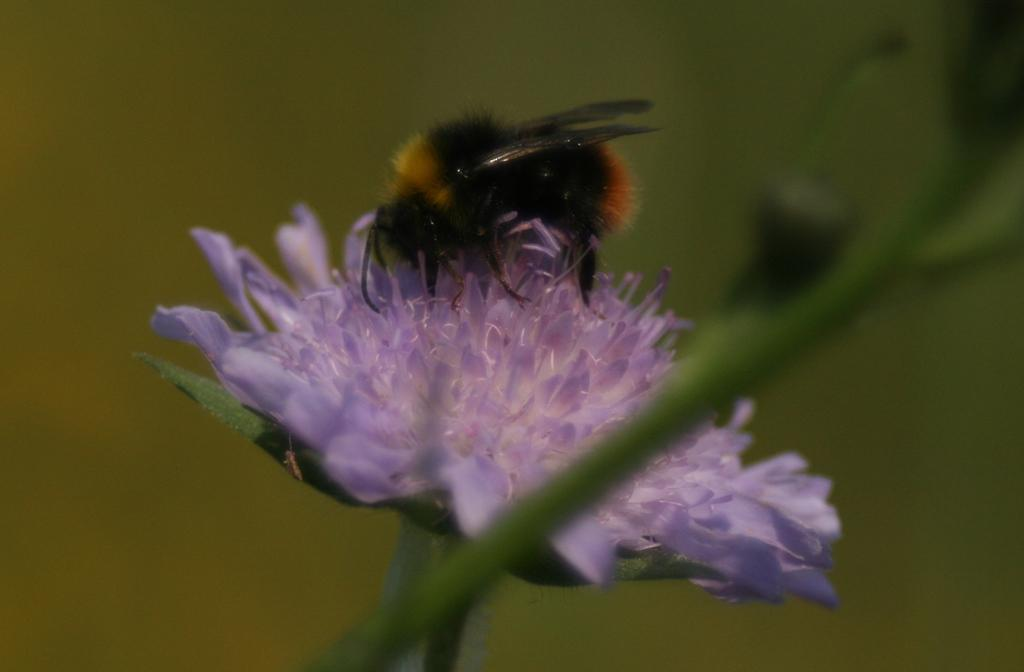What is present on the flower in the image? There is an insect on the flower in the image. Can you describe the insect's location on the flower? The insect is on the flower in the image. What part of the flower is visible in the image? The stem of the flower is visible in the image. How would you describe the background of the image? The background of the image is blurry. Can you see a lamp illuminating the insect in the image? There is no lamp present in the image; it only features an insect on a flower with a visible stem, and a blurry background. 